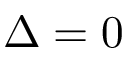Convert formula to latex. <formula><loc_0><loc_0><loc_500><loc_500>\Delta = 0</formula> 